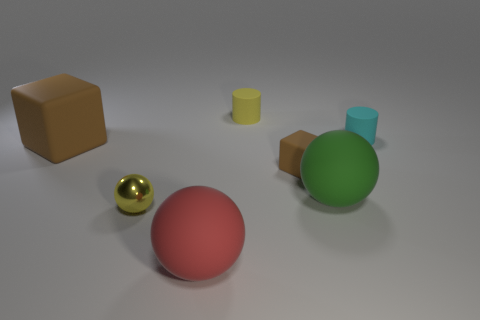Are there any other things that have the same material as the yellow ball?
Your answer should be very brief. No. There is a thing that is the same color as the tiny sphere; what is its size?
Provide a succinct answer. Small. Are there any matte spheres of the same color as the small block?
Give a very brief answer. No. The other matte cylinder that is the same size as the cyan cylinder is what color?
Your answer should be very brief. Yellow. Is the cyan thing the same shape as the yellow rubber object?
Offer a very short reply. Yes. What material is the small yellow object that is behind the tiny cyan thing?
Make the answer very short. Rubber. What color is the shiny ball?
Make the answer very short. Yellow. There is a yellow object that is behind the big matte block; is it the same size as the brown matte block that is on the right side of the big red rubber ball?
Provide a short and direct response. Yes. There is a object that is both right of the tiny brown block and left of the cyan matte cylinder; how big is it?
Your answer should be compact. Large. What is the color of the other small object that is the same shape as the cyan matte object?
Make the answer very short. Yellow. 